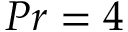<formula> <loc_0><loc_0><loc_500><loc_500>P r = 4</formula> 